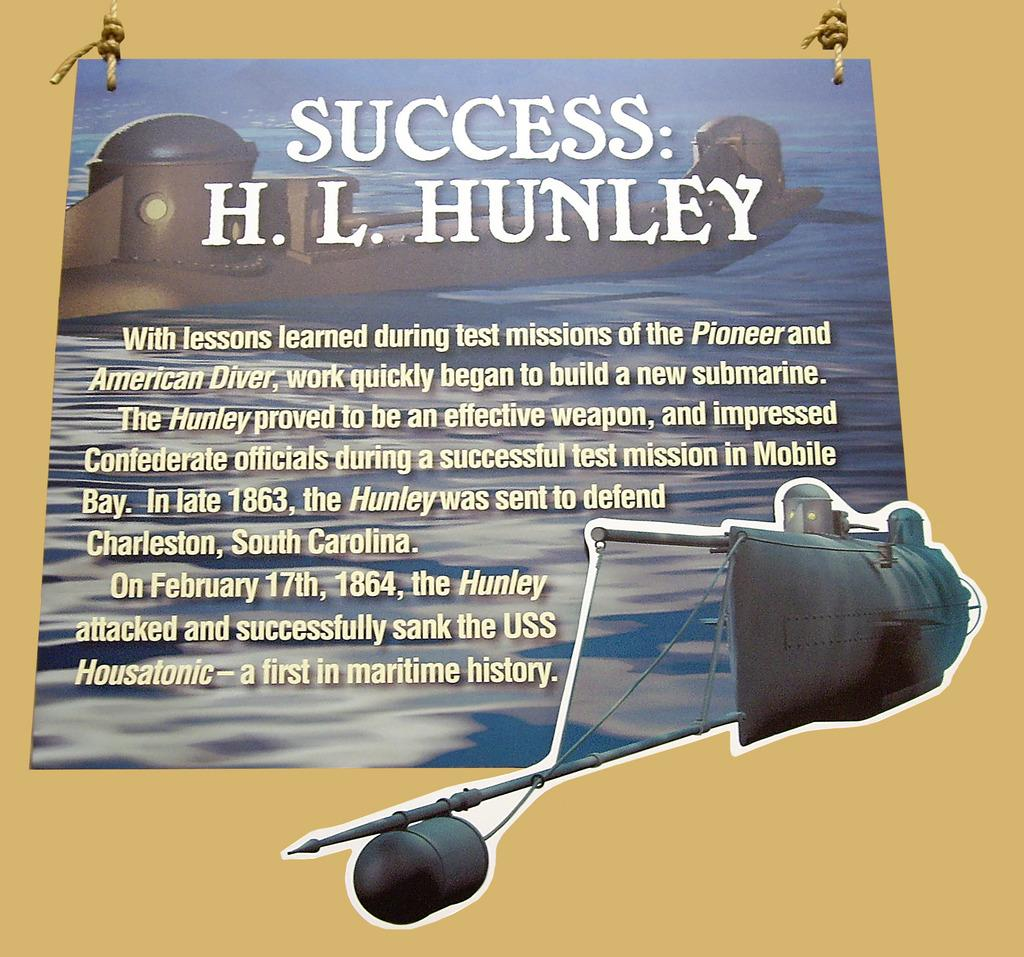Provide a one-sentence caption for the provided image. a poster on a yellow background with the title Success: H. L. Hunley. 